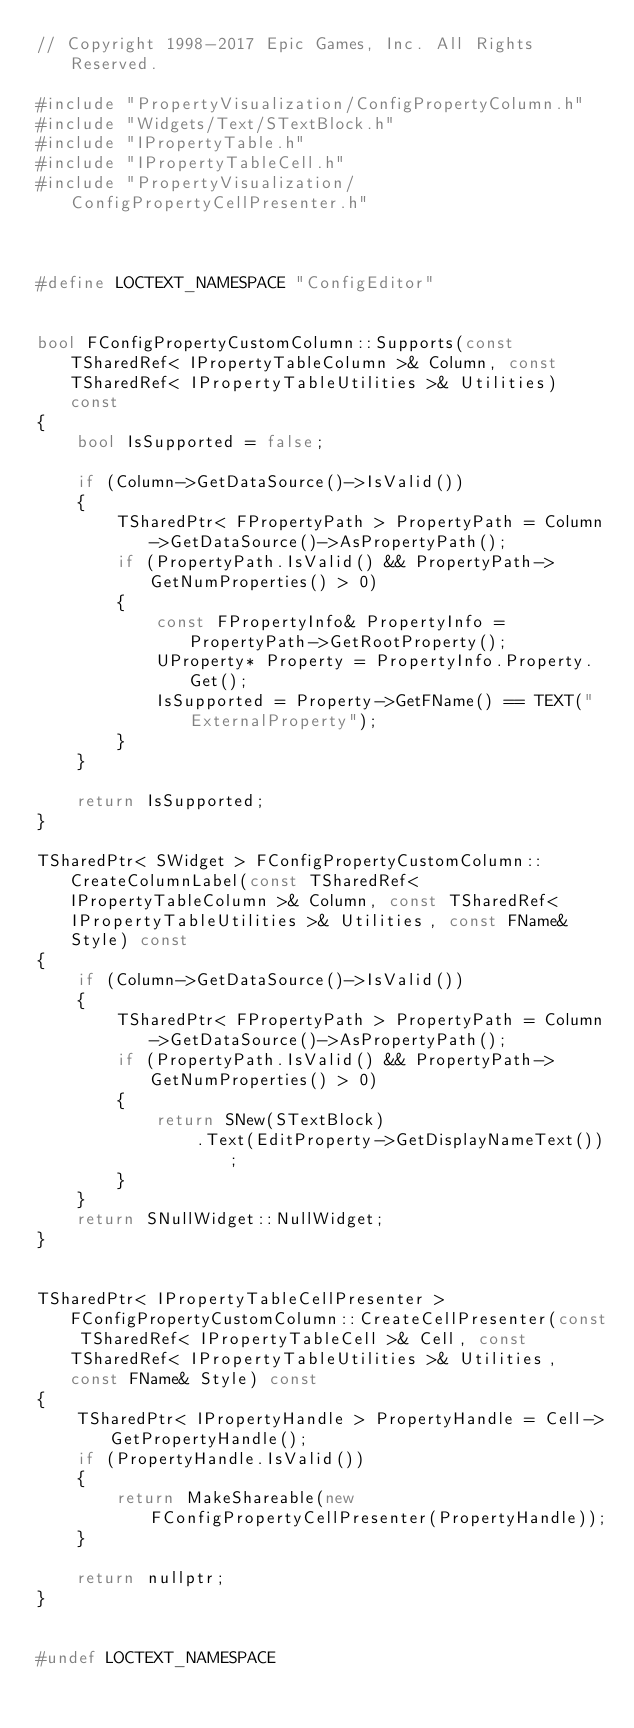<code> <loc_0><loc_0><loc_500><loc_500><_C++_>// Copyright 1998-2017 Epic Games, Inc. All Rights Reserved.

#include "PropertyVisualization/ConfigPropertyColumn.h"
#include "Widgets/Text/STextBlock.h"
#include "IPropertyTable.h"
#include "IPropertyTableCell.h"
#include "PropertyVisualization/ConfigPropertyCellPresenter.h"



#define LOCTEXT_NAMESPACE "ConfigEditor"


bool FConfigPropertyCustomColumn::Supports(const TSharedRef< IPropertyTableColumn >& Column, const TSharedRef< IPropertyTableUtilities >& Utilities) const
{
	bool IsSupported = false;

	if (Column->GetDataSource()->IsValid())
	{
		TSharedPtr< FPropertyPath > PropertyPath = Column->GetDataSource()->AsPropertyPath();
		if (PropertyPath.IsValid() && PropertyPath->GetNumProperties() > 0)
		{
			const FPropertyInfo& PropertyInfo = PropertyPath->GetRootProperty();
			UProperty* Property = PropertyInfo.Property.Get();
			IsSupported = Property->GetFName() == TEXT("ExternalProperty");
		}
	}

	return IsSupported;
}

TSharedPtr< SWidget > FConfigPropertyCustomColumn::CreateColumnLabel(const TSharedRef< IPropertyTableColumn >& Column, const TSharedRef< IPropertyTableUtilities >& Utilities, const FName& Style) const
{
	if (Column->GetDataSource()->IsValid())
	{
		TSharedPtr< FPropertyPath > PropertyPath = Column->GetDataSource()->AsPropertyPath();
		if (PropertyPath.IsValid() && PropertyPath->GetNumProperties() > 0)
		{
			return SNew(STextBlock)
				.Text(EditProperty->GetDisplayNameText());
		}
	}
	return SNullWidget::NullWidget;
}


TSharedPtr< IPropertyTableCellPresenter > FConfigPropertyCustomColumn::CreateCellPresenter(const TSharedRef< IPropertyTableCell >& Cell, const TSharedRef< IPropertyTableUtilities >& Utilities, const FName& Style) const
{
	TSharedPtr< IPropertyHandle > PropertyHandle = Cell->GetPropertyHandle();
	if (PropertyHandle.IsValid())
	{
		return MakeShareable(new FConfigPropertyCellPresenter(PropertyHandle));
	}

	return nullptr;
}


#undef LOCTEXT_NAMESPACE
</code> 